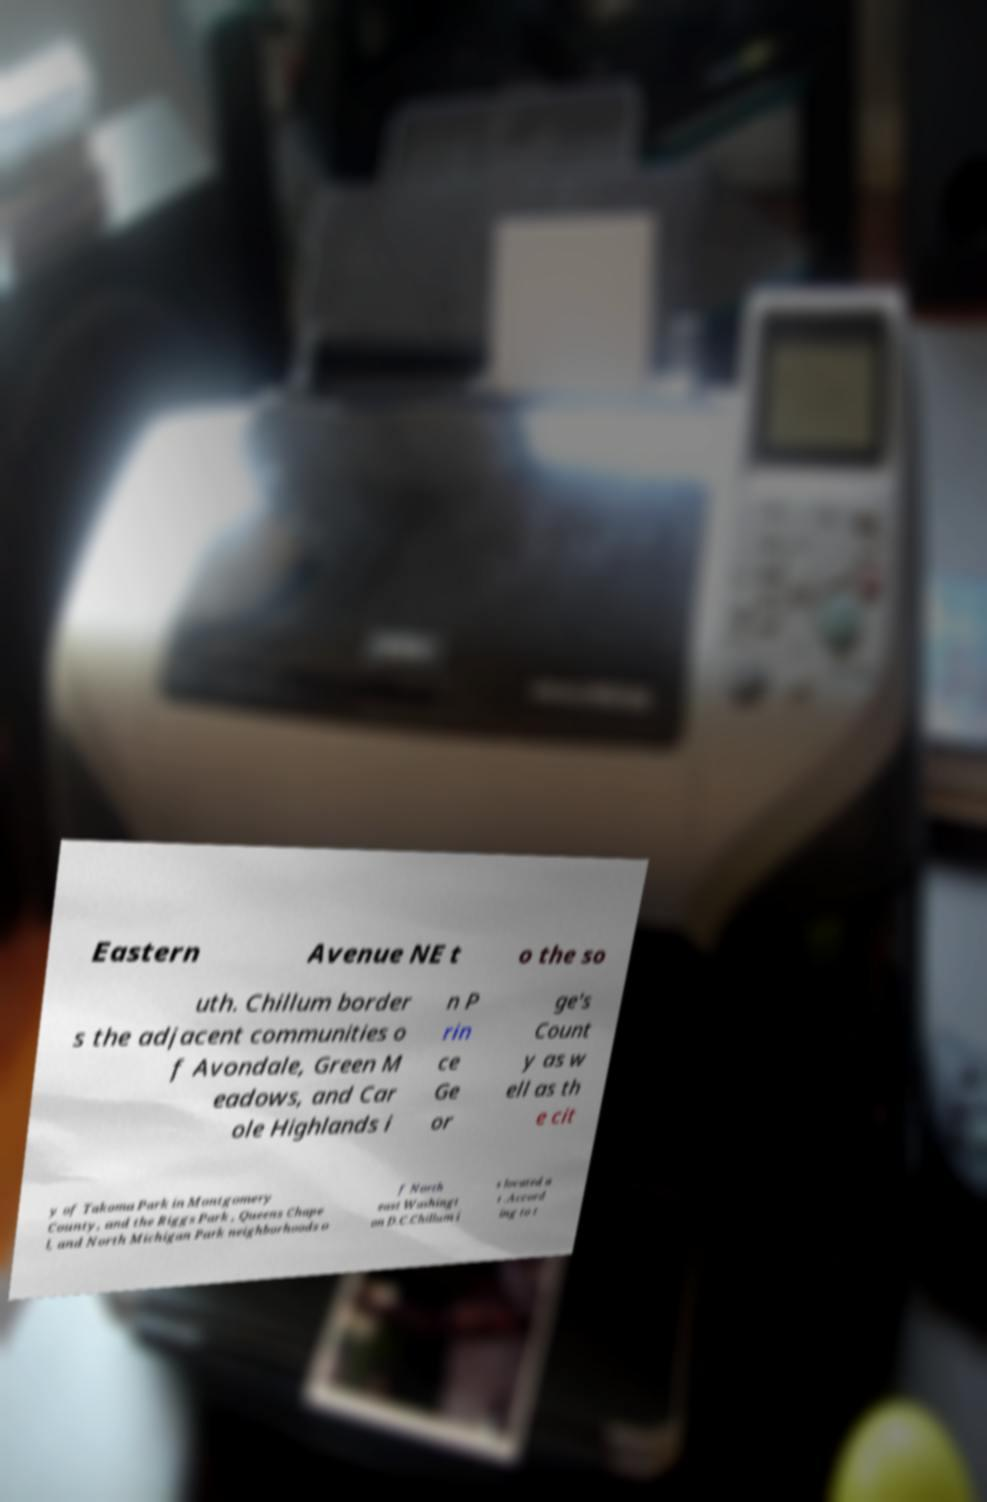There's text embedded in this image that I need extracted. Can you transcribe it verbatim? Eastern Avenue NE t o the so uth. Chillum border s the adjacent communities o f Avondale, Green M eadows, and Car ole Highlands i n P rin ce Ge or ge's Count y as w ell as th e cit y of Takoma Park in Montgomery County, and the Riggs Park , Queens Chape l, and North Michigan Park neighborhoods o f North east Washingt on D.C.Chillum i s located a t .Accord ing to t 